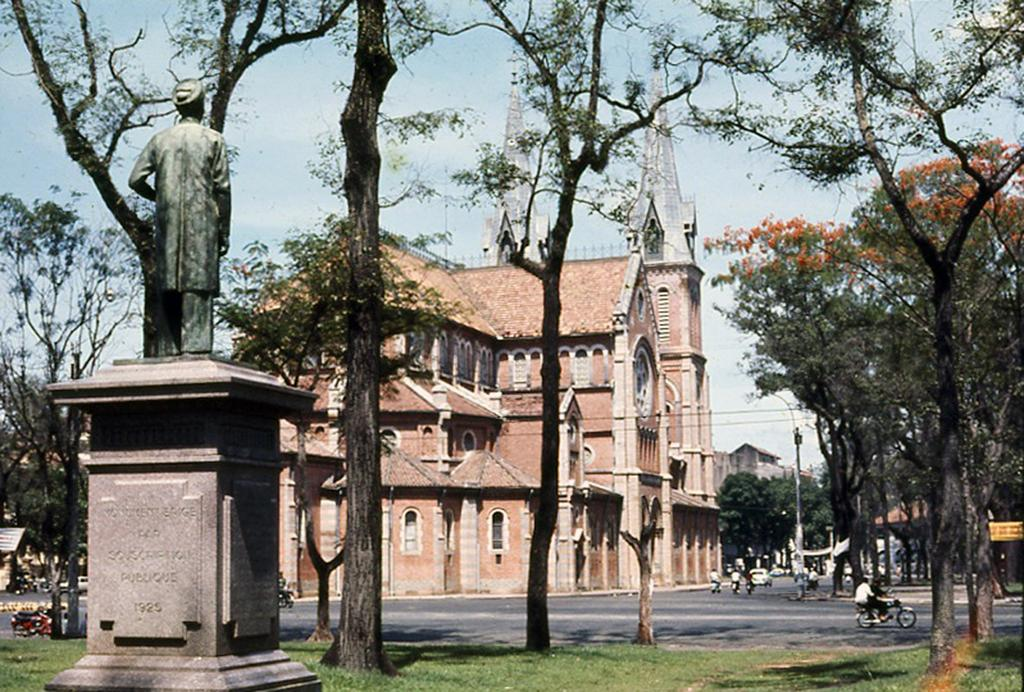What can be found on the left side of the image? There is a statue on the left side of the image. What type of natural elements are present in the image? There are trees, grass, and flowers visible in the image. What man-made structures can be seen in the image? There are buildings and poles in the image. What type of transportation is present in the image? Vehicles are present in the image. Are there any living beings visible in the image? Yes, people are visible in the image. What can be seen in the sky in the image? The sky is visible in the image, and there are clouds present. How many cats are sitting on the shirt in the image? There are no cats or shirts present in the image. What type of class is being held in the image? There is no class or educational setting depicted in the image. 